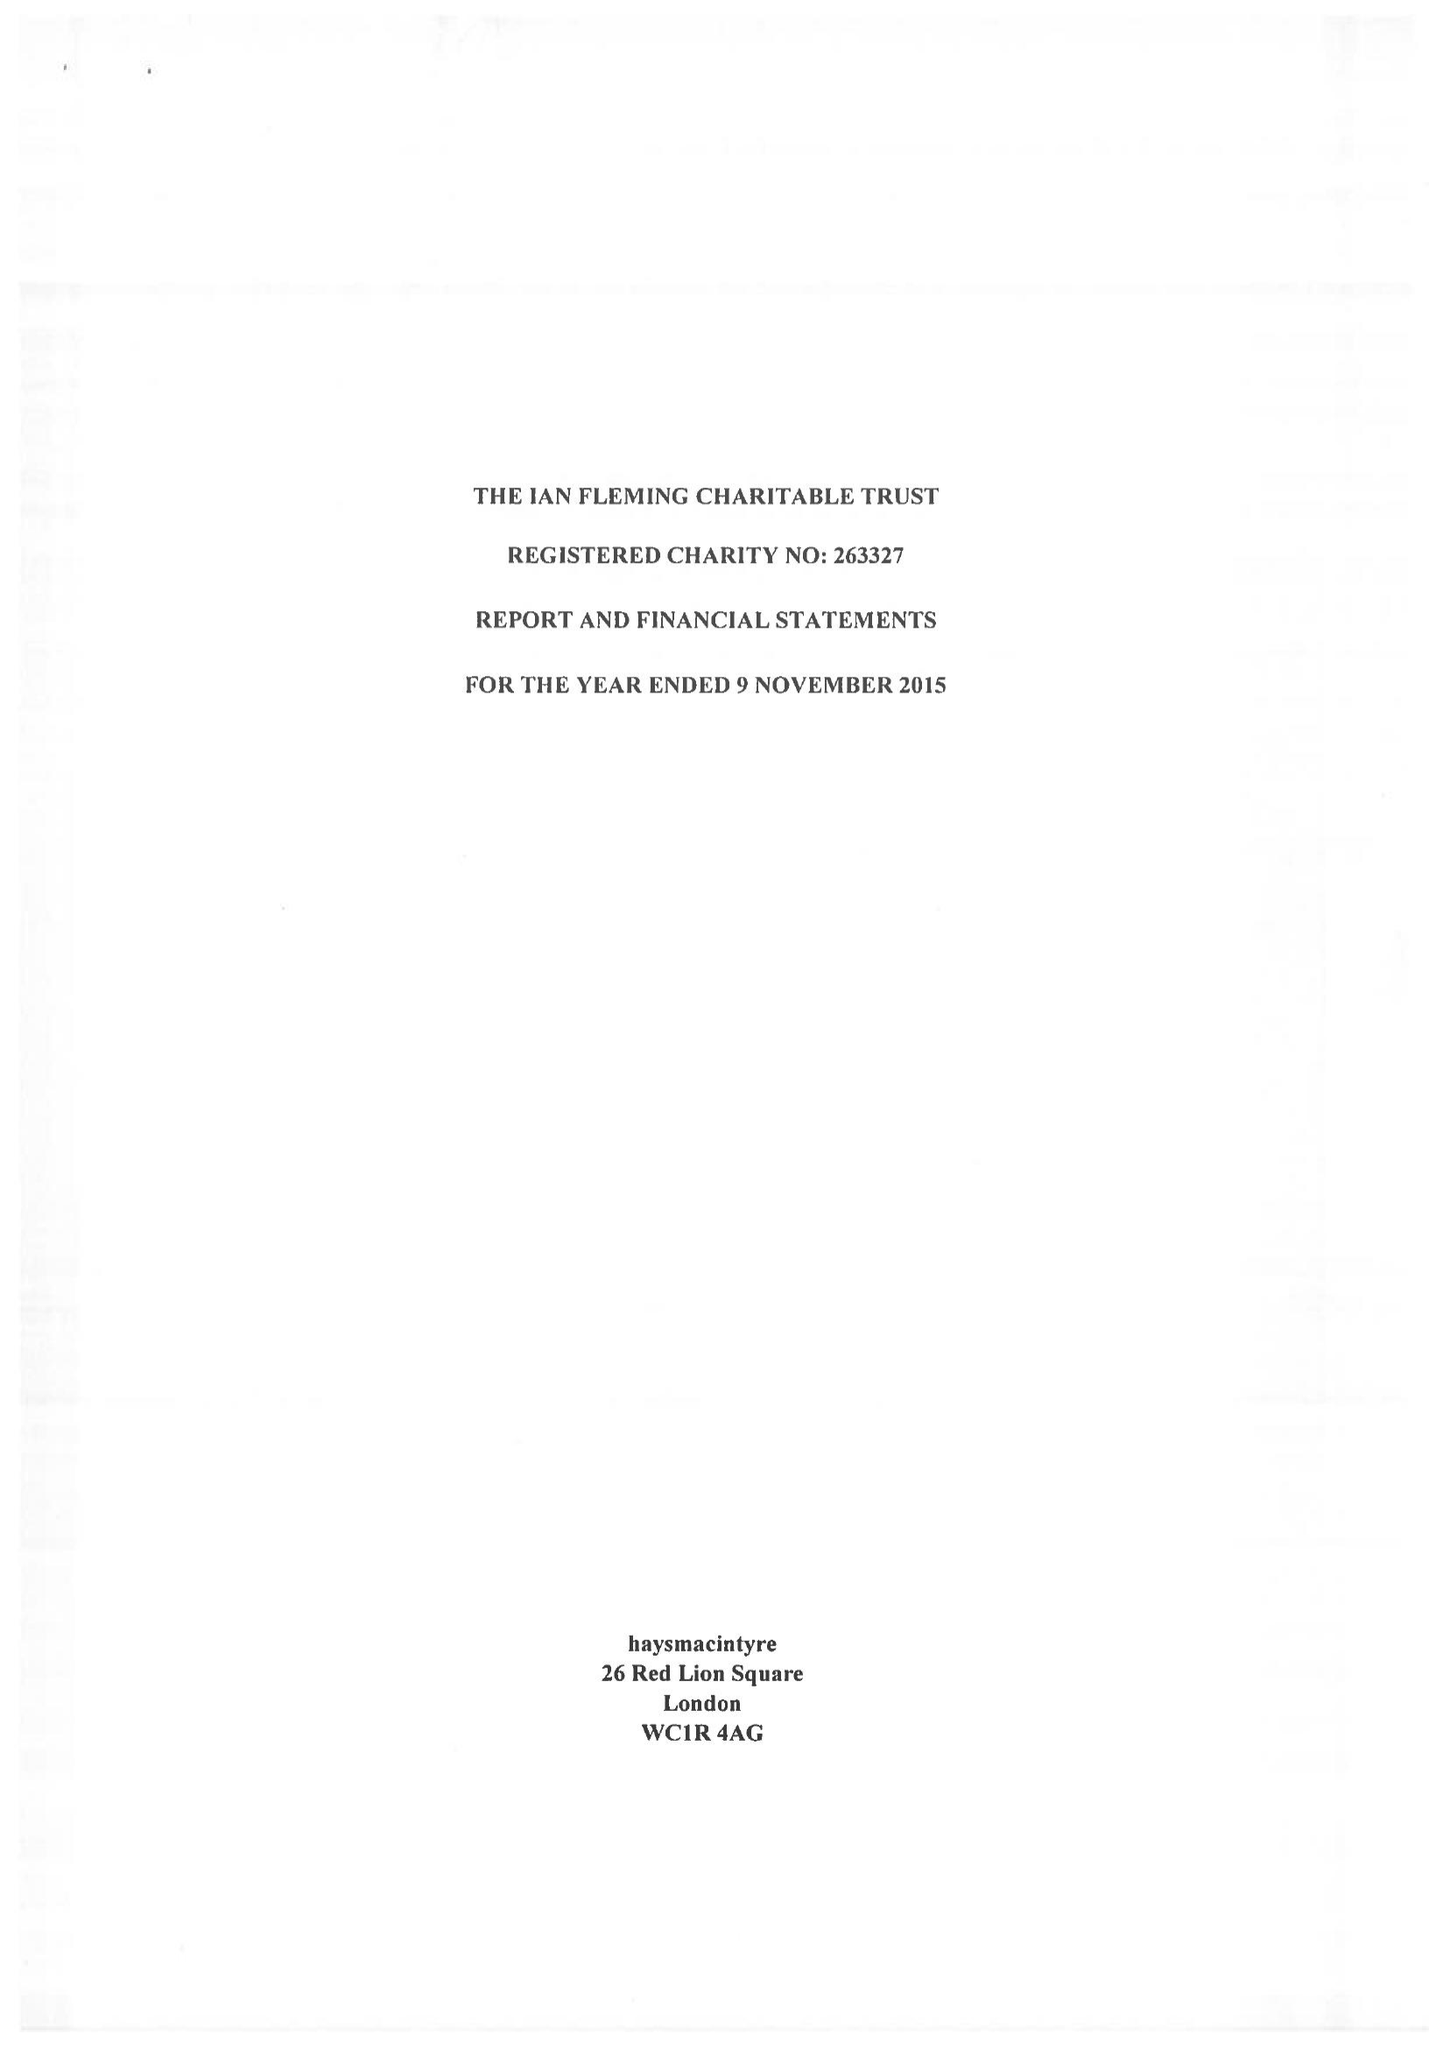What is the value for the address__post_town?
Answer the question using a single word or phrase. LONDON 